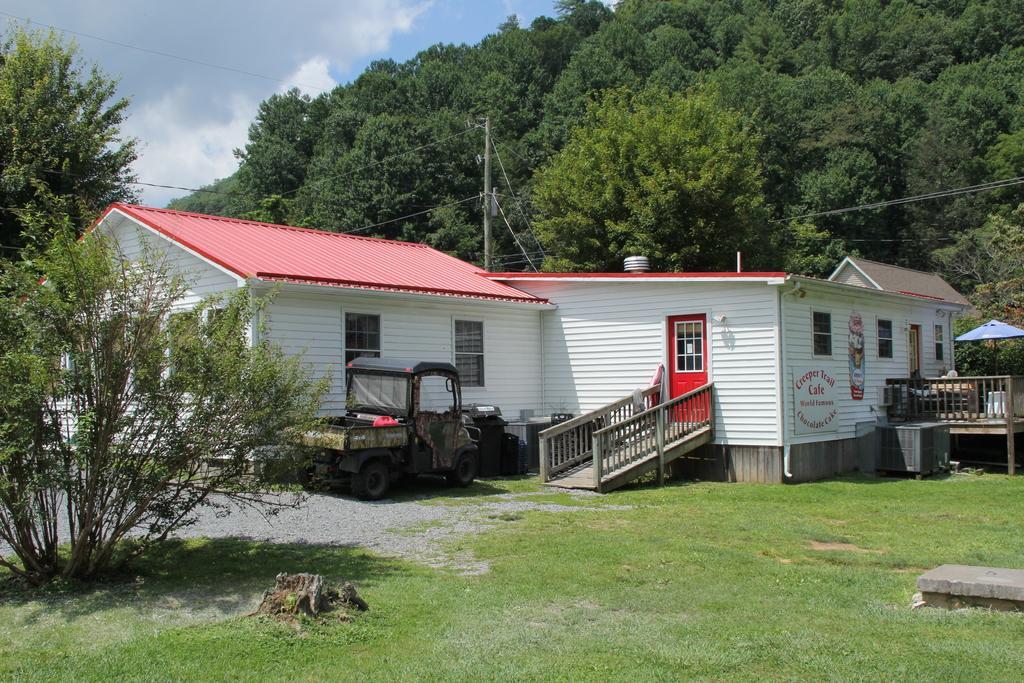Could you give a brief overview of what you see in this image? In this image there is a house with wooden stairs to the entrance of the house, beside the house there is a jeep parked, in front of the house there is grass on the surface, behind the house there are trees and electrical poles with cables on top of it. 